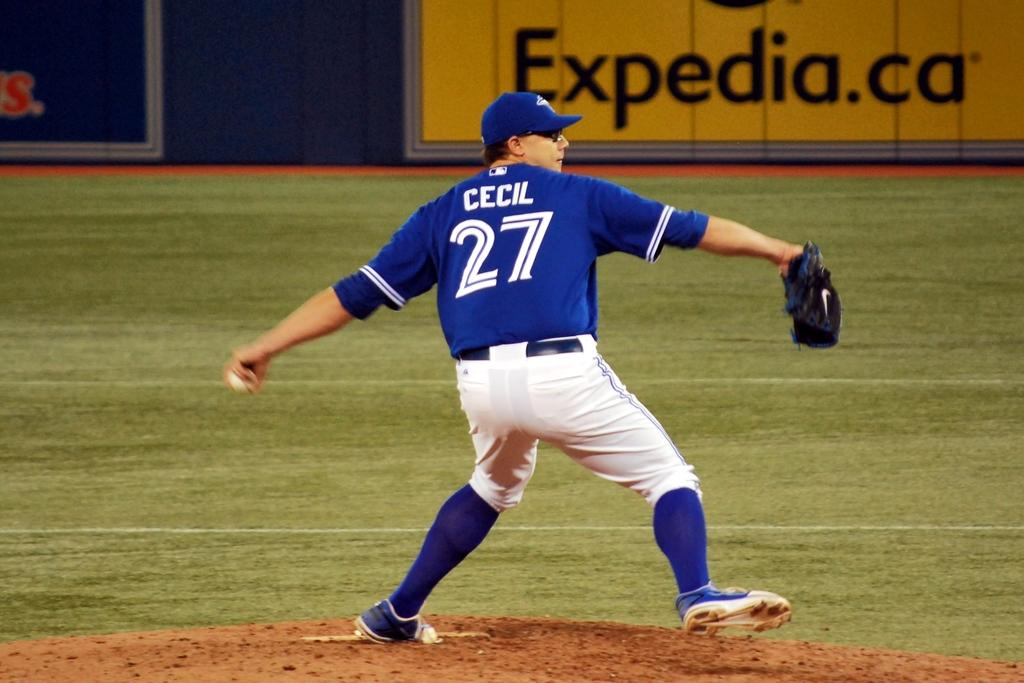<image>
Render a clear and concise summary of the photo. Number 27 whose name is Cecil wears a blue top and throws the ball in front of a large advert for Expedia. 